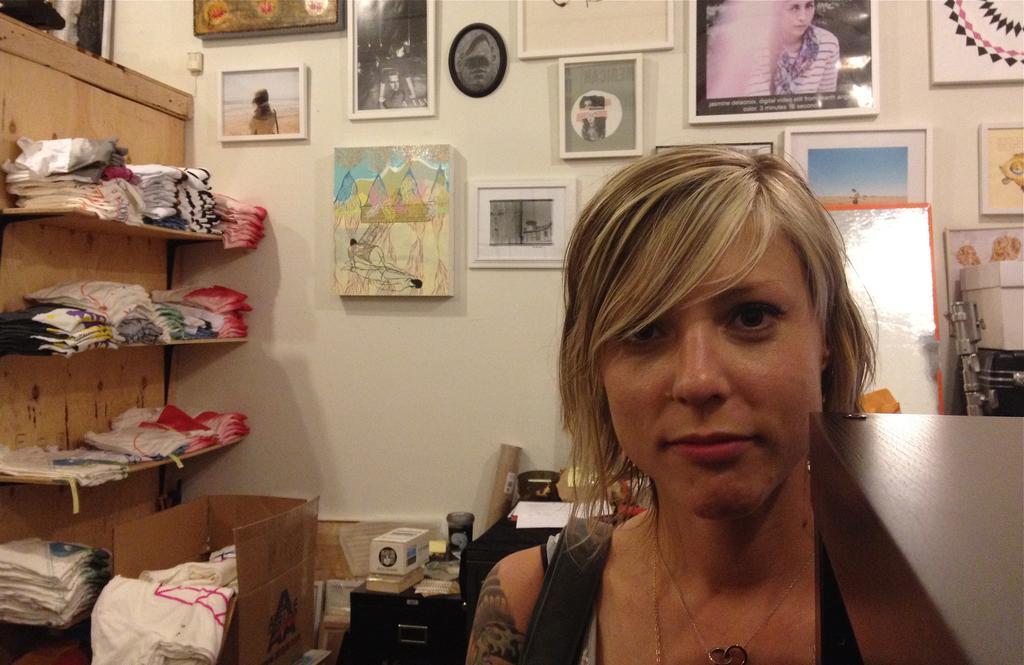Could you give a brief overview of what you see in this image? In the image we can see there is a lady and there are clothes kept on the racks. There are photo frames kept on the wall and there are boxes kept on the table. 